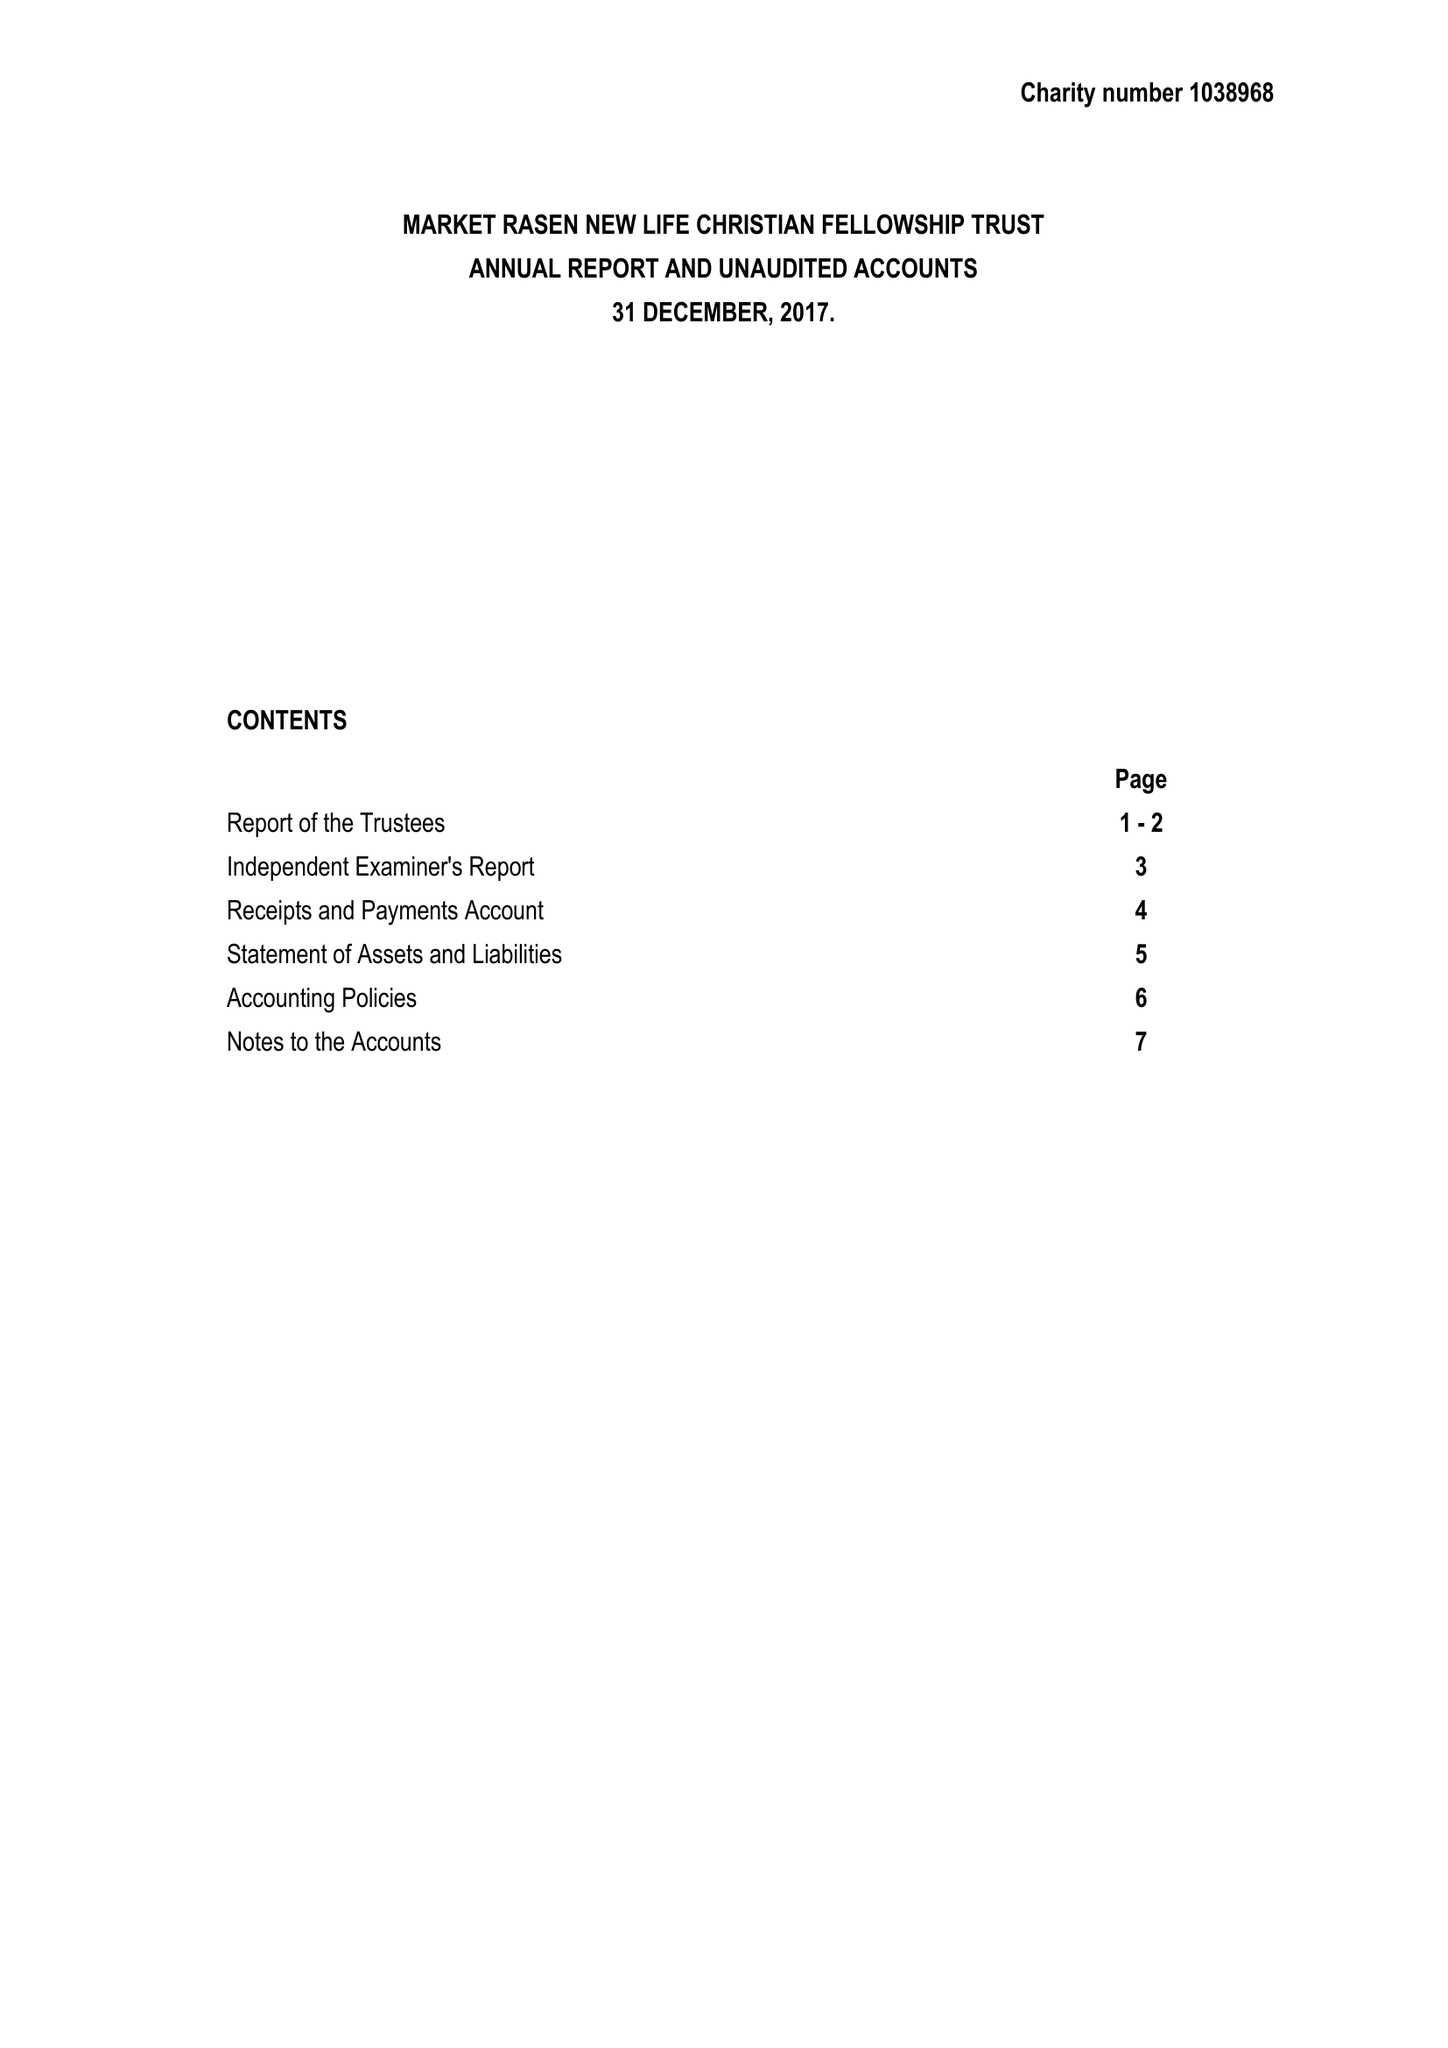What is the value for the spending_annually_in_british_pounds?
Answer the question using a single word or phrase. 47778.00 